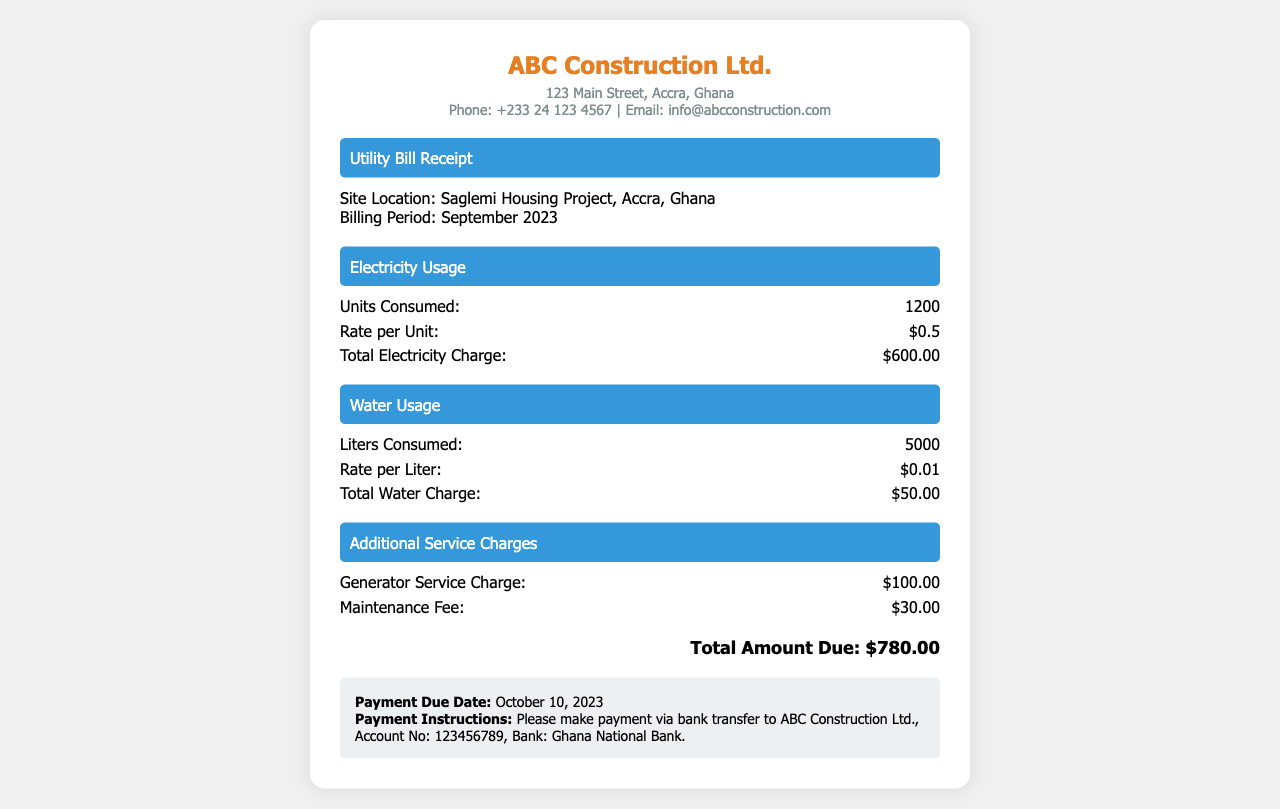What is the site location? The site location is mentioned in the document as Saglemi Housing Project, Accra, Ghana.
Answer: Saglemi Housing Project, Accra, Ghana What is the billing period? The billing period for the utility bill receipt is specified in the document as September 2023.
Answer: September 2023 How many liters of water were consumed? The total liters of water consumed are provided in the water usage section, which states 5000 liters.
Answer: 5000 What is the rate per unit of electricity? The document specifies the rate per unit of electricity as $0.5.
Answer: $0.5 What is the total amount due? The total amount due is the final figure summarized at the bottom of the document, which is $780.00.
Answer: $780.00 What is the total charge for water? The total water charge is explicitly stated in the document as $50.00.
Answer: $50.00 What additional service charge is listed? The document includes specific additional service charges, such as the Generator Service Charge listed as $100.00.
Answer: $100.00 When is the payment due date? The payment due date is stated in the payment information section as October 10, 2023.
Answer: October 10, 2023 What is the maintenance fee? The maintenance fee is mentioned in the additional service charges section as $30.00.
Answer: $30.00 